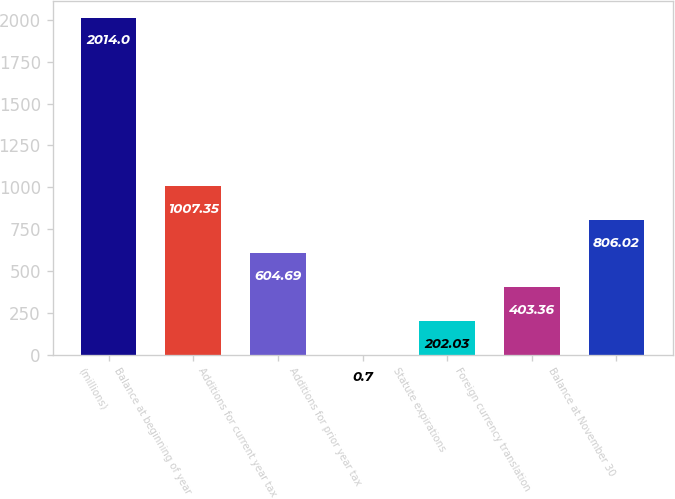<chart> <loc_0><loc_0><loc_500><loc_500><bar_chart><fcel>(millions)<fcel>Balance at beginning of year<fcel>Additions for current year tax<fcel>Additions for prior year tax<fcel>Statute expirations<fcel>Foreign currency translation<fcel>Balance at November 30<nl><fcel>2014<fcel>1007.35<fcel>604.69<fcel>0.7<fcel>202.03<fcel>403.36<fcel>806.02<nl></chart> 